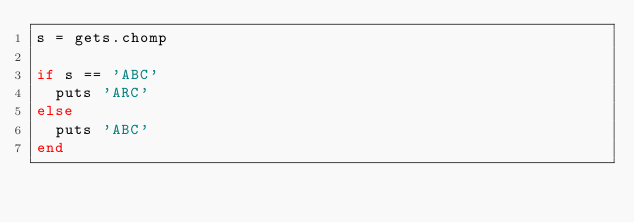Convert code to text. <code><loc_0><loc_0><loc_500><loc_500><_Ruby_>s = gets.chomp

if s == 'ABC'
  puts 'ARC'
else
  puts 'ABC'
end</code> 